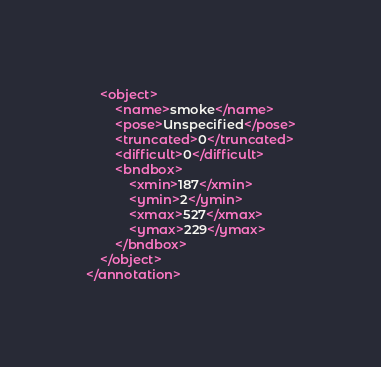<code> <loc_0><loc_0><loc_500><loc_500><_XML_>	<object>
		<name>smoke</name>
		<pose>Unspecified</pose>
		<truncated>0</truncated>
		<difficult>0</difficult>
		<bndbox>
			<xmin>187</xmin>
			<ymin>2</ymin>
			<xmax>527</xmax>
			<ymax>229</ymax>
		</bndbox>
	</object>
</annotation>
</code> 